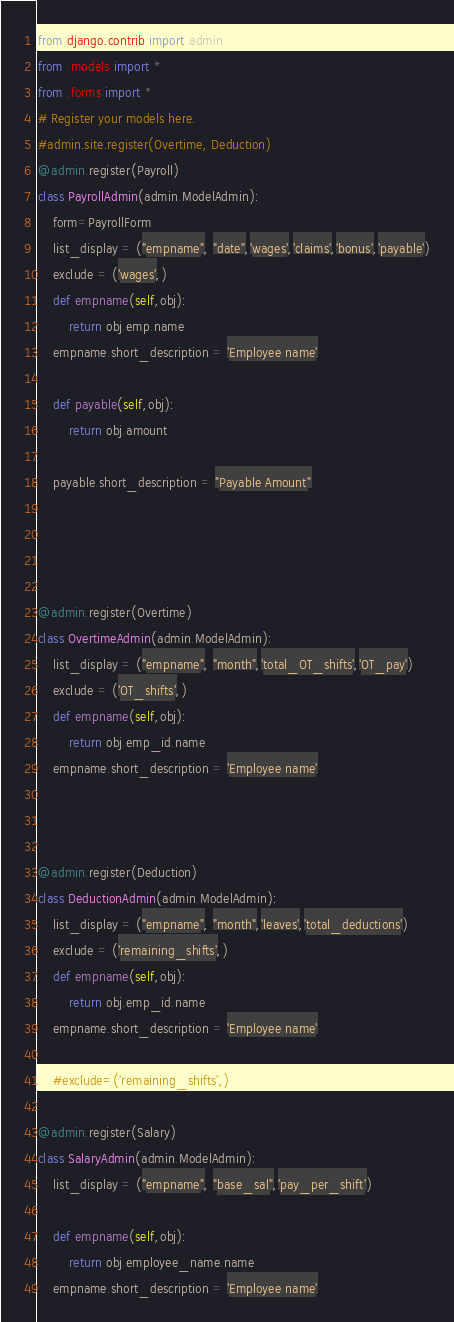<code> <loc_0><loc_0><loc_500><loc_500><_Python_>from django.contrib import admin
from .models import *
from .forms import *
# Register your models here.
#admin.site.register(Overtime, Deduction)
@admin.register(Payroll)
class PayrollAdmin(admin.ModelAdmin):
    form=PayrollForm
    list_display = ("empname", "date",'wages','claims','bonus','payable')
    exclude = ('wages',)
    def empname(self,obj):
        return obj.emp.name
    empname.short_description = 'Employee name'

    def payable(self,obj):
        return obj.amount
    
    payable.short_description = "Payable Amount"

    
    

@admin.register(Overtime)
class OvertimeAdmin(admin.ModelAdmin):
    list_display = ("empname", "month",'total_OT_shifts','OT_pay')
    exclude = ('OT_shifts',)
    def empname(self,obj):
        return obj.emp_id.name
    empname.short_description = 'Employee name'
    
    

@admin.register(Deduction)
class DeductionAdmin(admin.ModelAdmin):
    list_display = ("empname", "month",'leaves','total_deductions')
    exclude = ('remaining_shifts',)
    def empname(self,obj):
        return obj.emp_id.name
    empname.short_description = 'Employee name'

    #exclude=('remaining_shifts',)

@admin.register(Salary)
class SalaryAdmin(admin.ModelAdmin):
    list_display = ("empname", "base_sal",'pay_per_shift')

    def empname(self,obj):
        return obj.employee_name.name
    empname.short_description = 'Employee name'</code> 